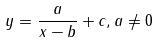Convert formula to latex. <formula><loc_0><loc_0><loc_500><loc_500>y = \frac { a } { x - b } + c , a \ne 0</formula> 